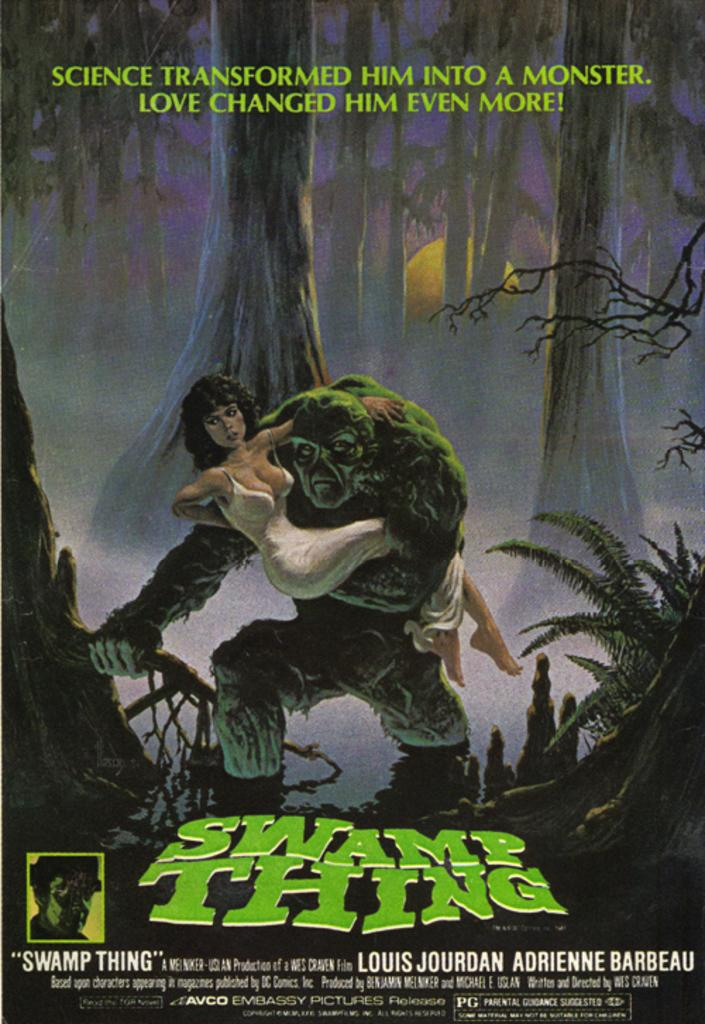<image>
Provide a brief description of the given image. A cover of the film Swamp thing directed by Louis Jourdan Adrienne barbeau. 